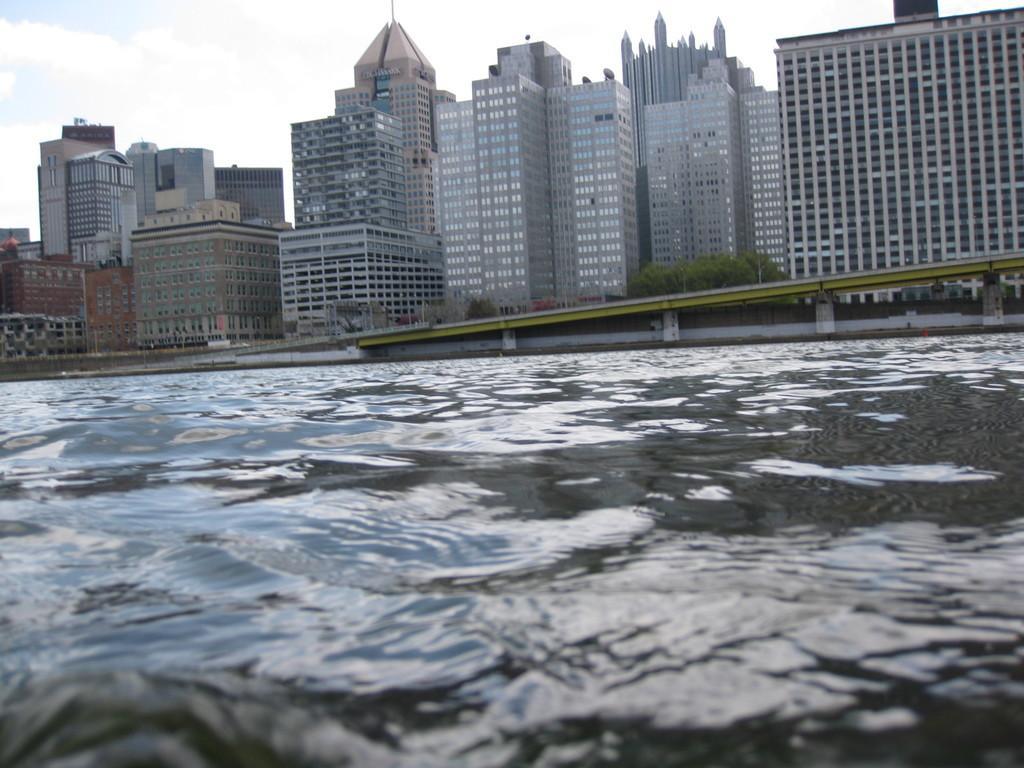In one or two sentences, can you explain what this image depicts? Here we can see water. Background there are buildings, plants and bridge. Sky is cloudy. 